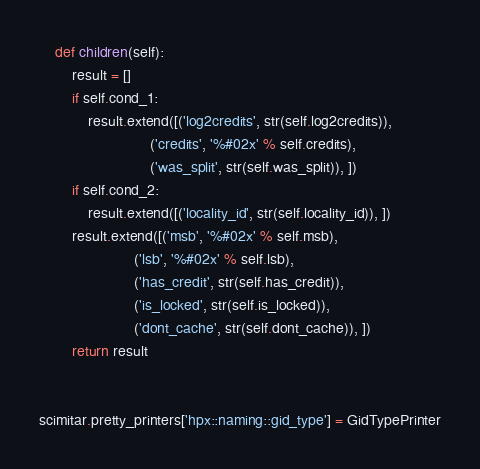Convert code to text. <code><loc_0><loc_0><loc_500><loc_500><_Python_>    def children(self):
        result = []
        if self.cond_1:
            result.extend([('log2credits', str(self.log2credits)),
                           ('credits', '%#02x' % self.credits),
                           ('was_split', str(self.was_split)), ])
        if self.cond_2:
            result.extend([('locality_id', str(self.locality_id)), ])
        result.extend([('msb', '%#02x' % self.msb),
                       ('lsb', '%#02x' % self.lsb),
                       ('has_credit', str(self.has_credit)),
                       ('is_locked', str(self.is_locked)),
                       ('dont_cache', str(self.dont_cache)), ])
        return result


scimitar.pretty_printers['hpx::naming::gid_type'] = GidTypePrinter
</code> 